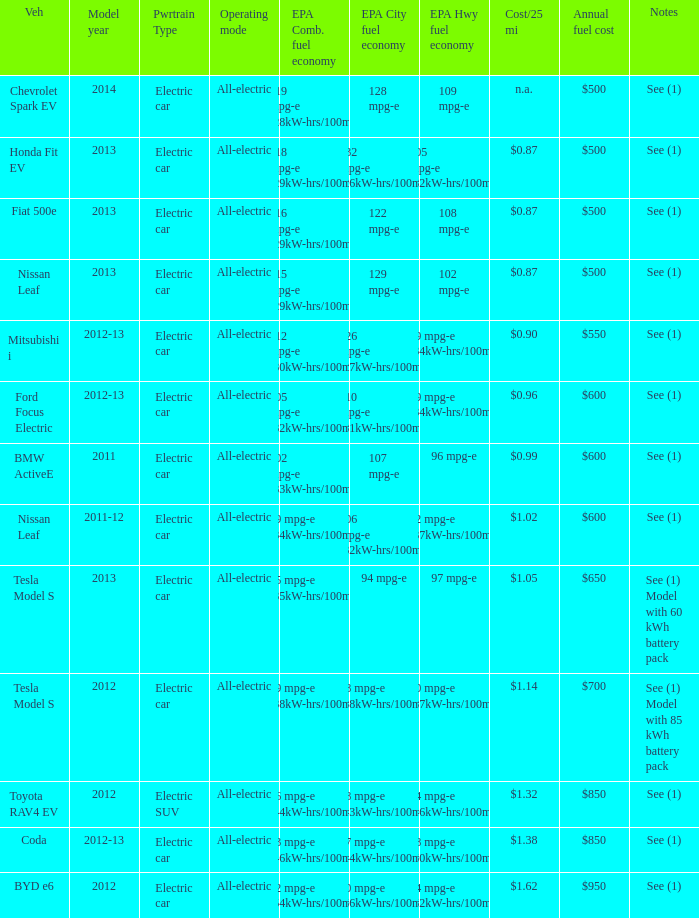What vehicle has an epa highway fuel economy of 109 mpg-e? Chevrolet Spark EV. 